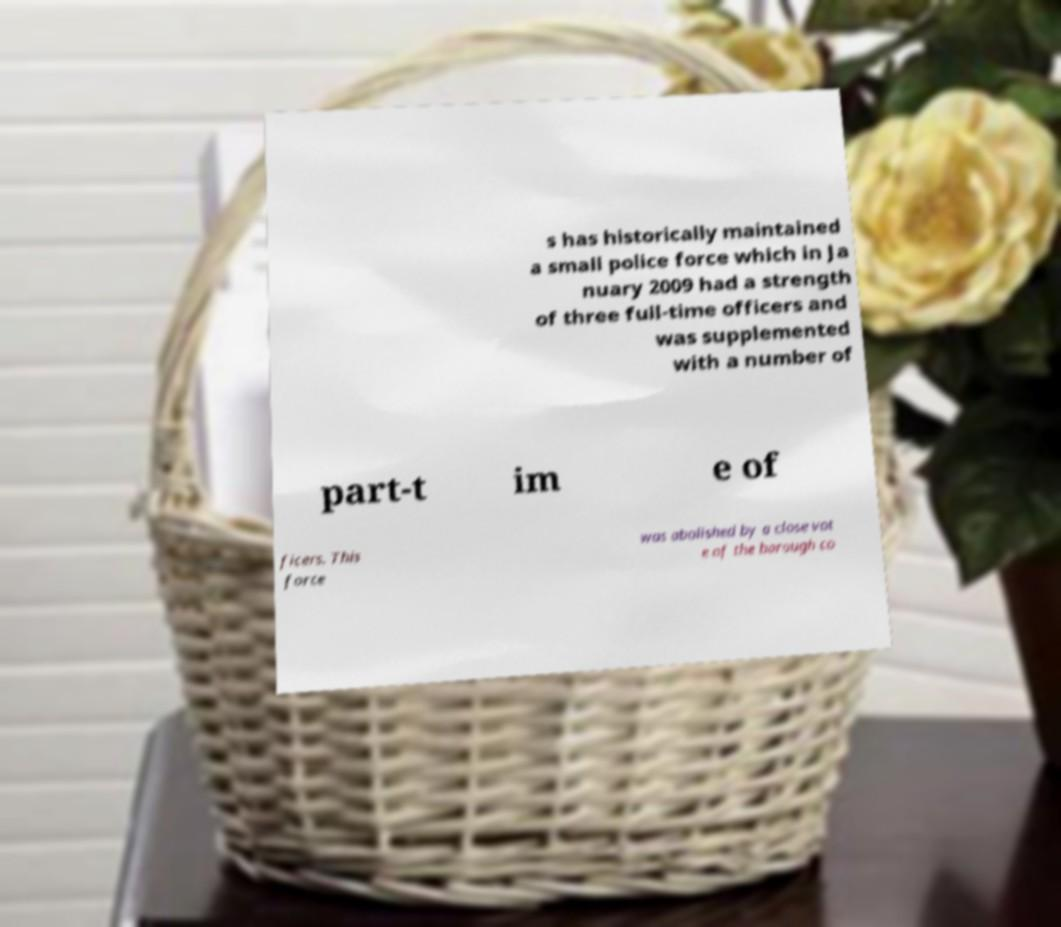For documentation purposes, I need the text within this image transcribed. Could you provide that? s has historically maintained a small police force which in Ja nuary 2009 had a strength of three full-time officers and was supplemented with a number of part-t im e of ficers. This force was abolished by a close vot e of the borough co 